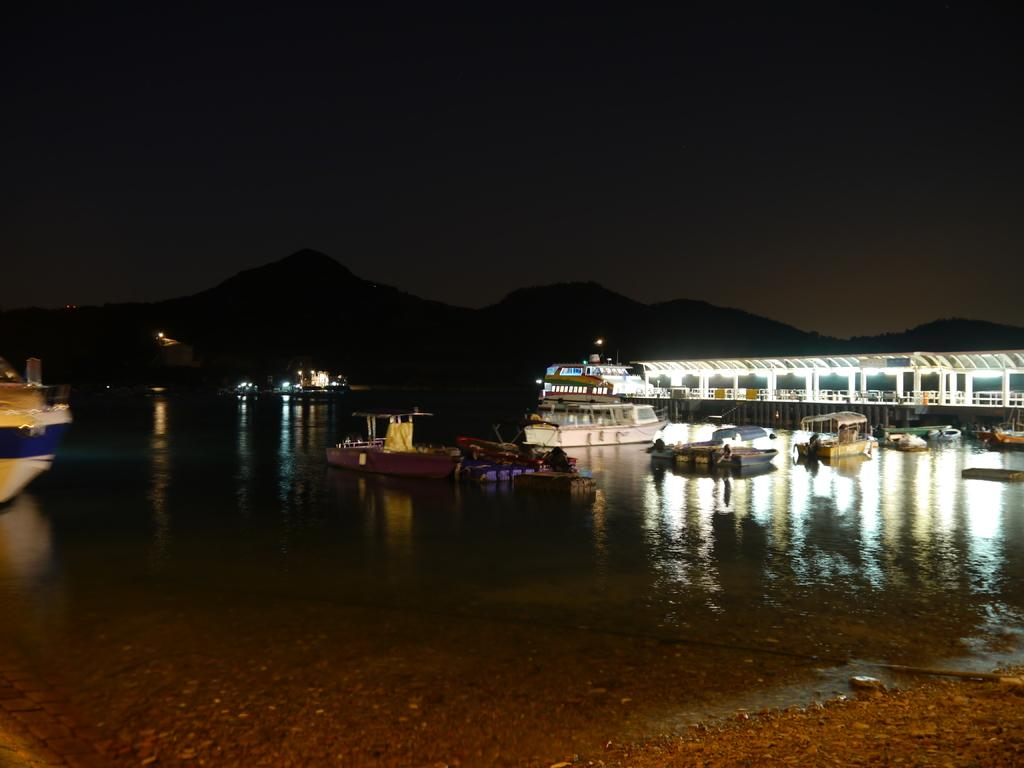What is the main subject of the image? The main subject of the image is boats floating on water. What can be seen in the background of the image? In the background of the image, there are hills and the sky visible. Can you describe the water in the image? The water is where the boats are floating. What is the value of the middle boat in the image? There is no indication of value or price associated with the boats in the image. 